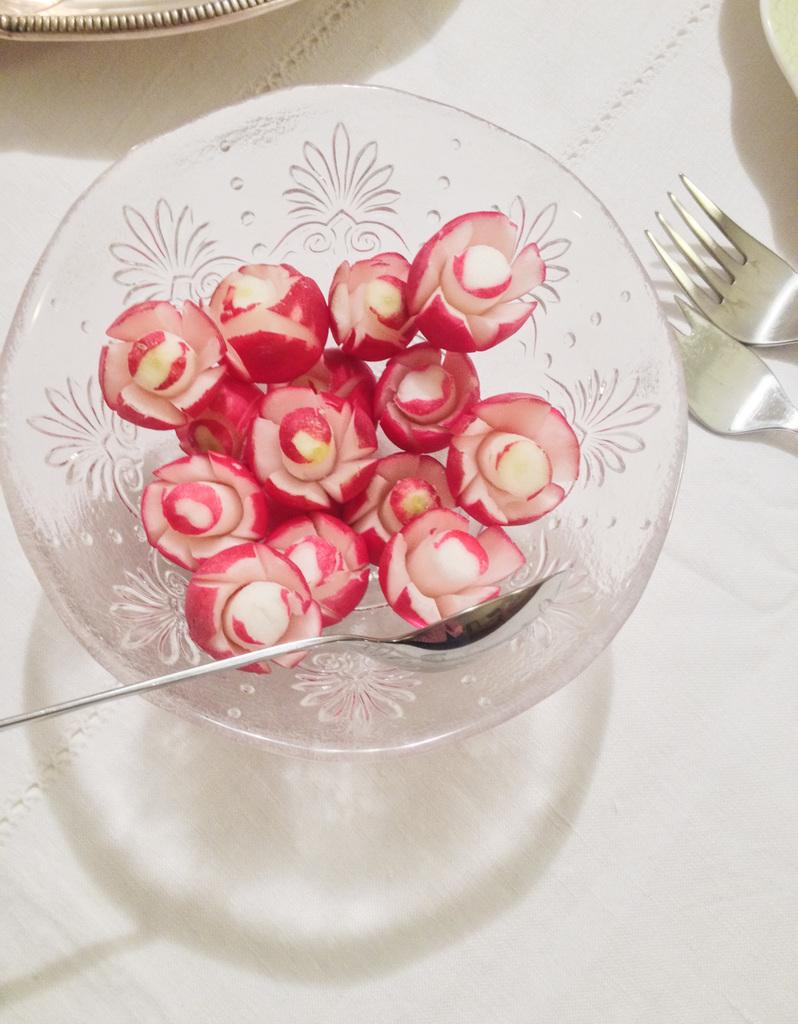What type of food is in the glass bowl in the image? There is a fruit craving in a glass bowl in the image. What utensil is visible in the image? There is a spoon in the image. What other utensils are present in the image? There are forks in the image. What is the color of the surface in the image? The surface in the image is white. How many clocks are hanging on the wall in the image? There are no clocks visible in the image. What type of haircut does the fruit have in the image? The fruit does not have a haircut, as it is not a living being. 